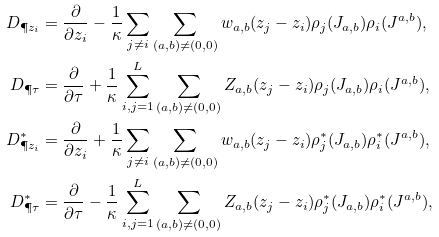<formula> <loc_0><loc_0><loc_500><loc_500>D _ { \P { z _ { i } } } & = \frac { \partial } { \partial z _ { i } } - \frac { 1 } { \kappa } \sum _ { j \neq i } \sum _ { ( a , b ) \neq ( 0 , 0 ) } w _ { a , b } ( z _ { j } - z _ { i } ) \rho _ { j } ( J _ { a , b } ) \rho _ { i } ( J ^ { a , b } ) , \\ D _ { \P { \tau } } & = \frac { \partial } { \partial \tau } + \frac { 1 } { \kappa } \sum _ { i , j = 1 } ^ { L } \sum _ { ( a , b ) \neq ( 0 , 0 ) } Z _ { a , b } ( z _ { j } - z _ { i } ) \rho _ { j } ( J _ { a , b } ) \rho _ { i } ( J ^ { a , b } ) , \\ D ^ { \ast } _ { \P { z _ { i } } } & = \frac { \partial } { \partial z _ { i } } + \frac { 1 } { \kappa } \sum _ { j \neq i } \sum _ { ( a , b ) \neq ( 0 , 0 ) } w _ { a , b } ( z _ { j } - z _ { i } ) \rho ^ { \ast } _ { j } ( J _ { a , b } ) \rho ^ { \ast } _ { i } ( J ^ { a , b } ) , \\ D ^ { \ast } _ { \P { \tau } } & = \frac { \partial } { \partial \tau } - \frac { 1 } { \kappa } \sum _ { i , j = 1 } ^ { L } \sum _ { ( a , b ) \neq ( 0 , 0 ) } Z _ { a , b } ( z _ { j } - z _ { i } ) \rho ^ { \ast } _ { j } ( J _ { a , b } ) \rho ^ { \ast } _ { i } ( J ^ { a , b } ) ,</formula> 